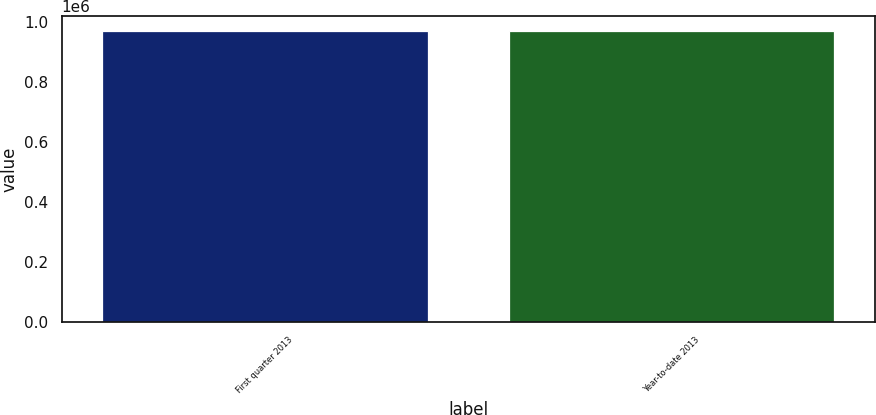<chart> <loc_0><loc_0><loc_500><loc_500><bar_chart><fcel>First quarter 2013<fcel>Year-to-date 2013<nl><fcel>972292<fcel>972292<nl></chart> 